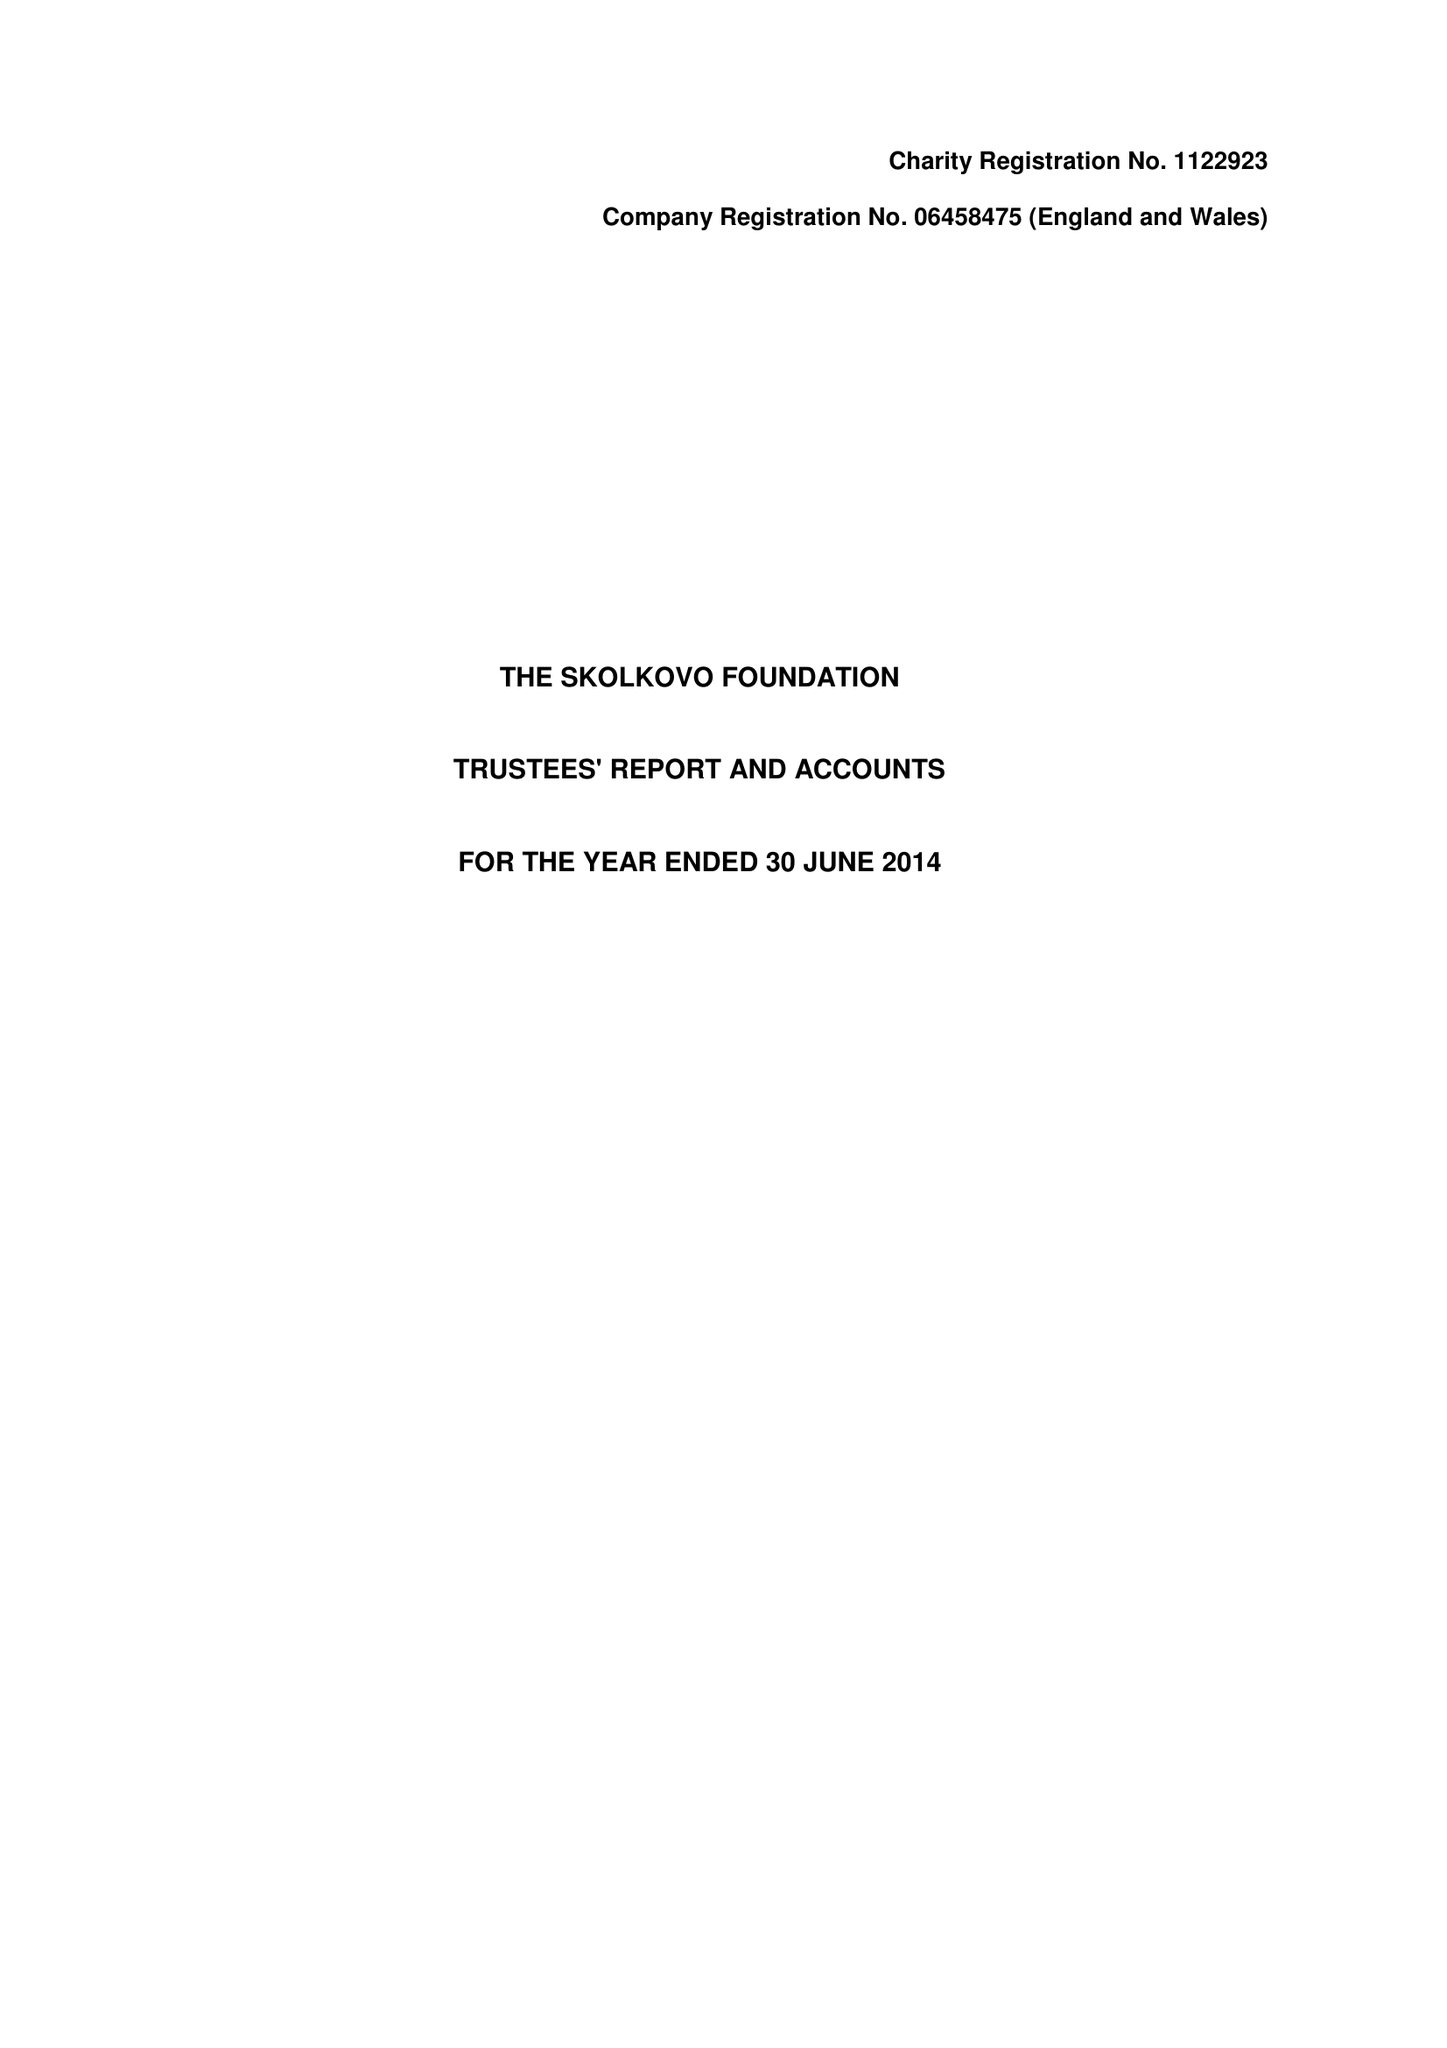What is the value for the charity_number?
Answer the question using a single word or phrase. 1122923 